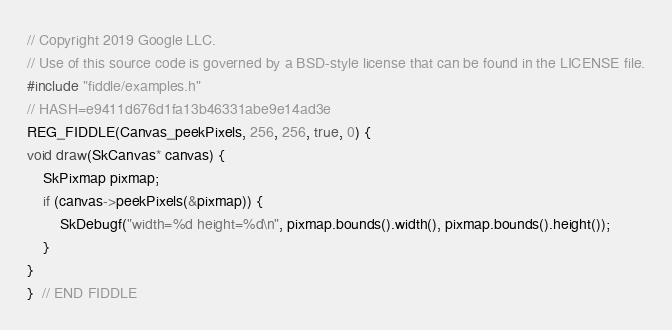Convert code to text. <code><loc_0><loc_0><loc_500><loc_500><_C++_>// Copyright 2019 Google LLC.
// Use of this source code is governed by a BSD-style license that can be found in the LICENSE file.
#include "fiddle/examples.h"
// HASH=e9411d676d1fa13b46331abe9e14ad3e
REG_FIDDLE(Canvas_peekPixels, 256, 256, true, 0) {
void draw(SkCanvas* canvas) {
    SkPixmap pixmap;
    if (canvas->peekPixels(&pixmap)) {
        SkDebugf("width=%d height=%d\n", pixmap.bounds().width(), pixmap.bounds().height());
    }
}
}  // END FIDDLE
</code> 